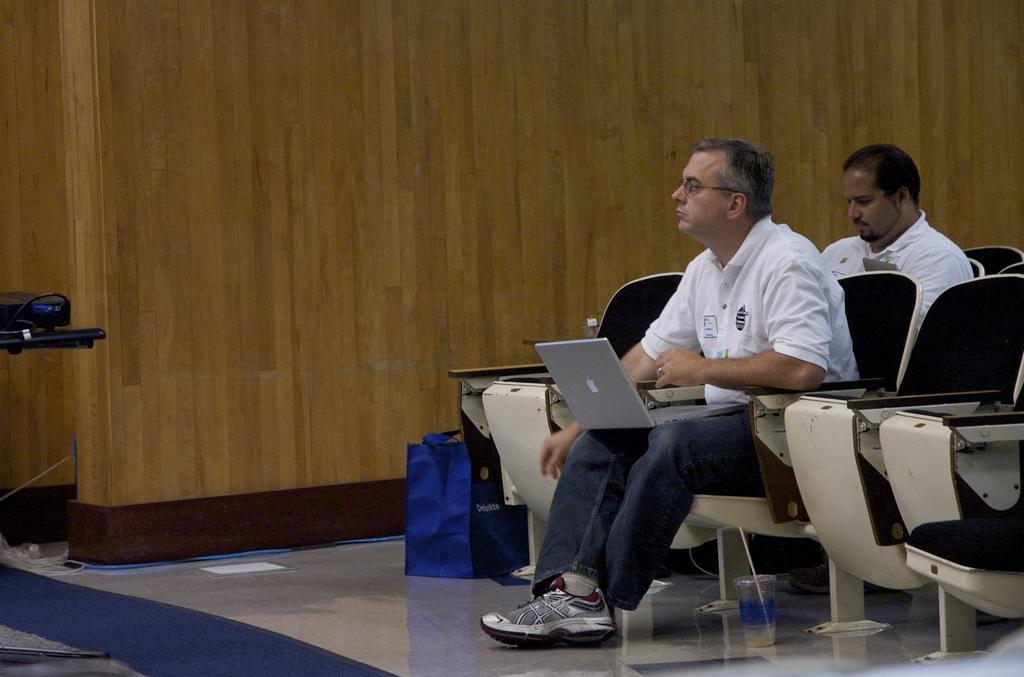How many people are in the image? There are two men in the image. What are the men doing in the image? The men are sitting on chairs. What objects are in front of the men? There is a laptop, a glass, and a bag in front of the men. What type of donkey can be seen in the jail cell in the image? There is no donkey or jail cell present in the image. 